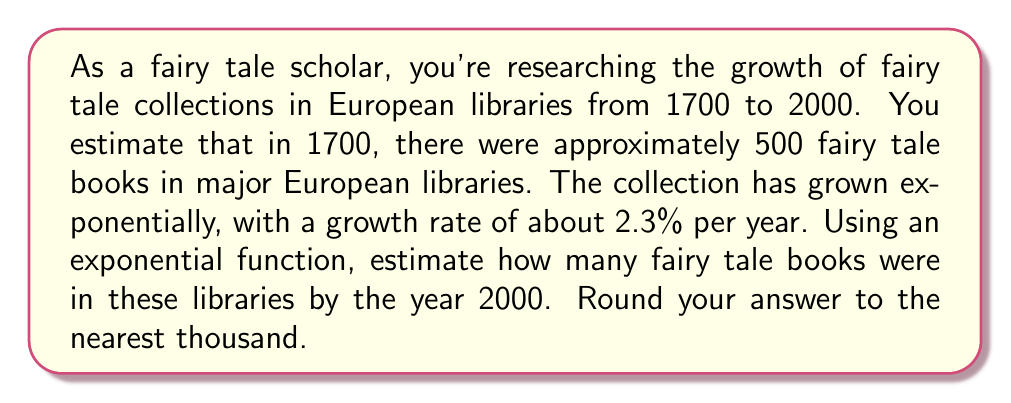Teach me how to tackle this problem. To solve this problem, we'll use the exponential growth function:

$$A(t) = A_0 \cdot (1 + r)^t$$

Where:
$A(t)$ is the amount after time $t$
$A_0$ is the initial amount
$r$ is the growth rate (as a decimal)
$t$ is the time in years

Given:
$A_0 = 500$ (initial number of books in 1700)
$r = 0.023$ (2.3% annual growth rate)
$t = 300$ (years from 1700 to 2000)

Let's substitute these values into our equation:

$$A(300) = 500 \cdot (1 + 0.023)^{300}$$

Now, let's calculate:

$$A(300) = 500 \cdot (1.023)^{300}$$

Using a calculator (as this involves a large exponent):

$$A(300) = 500 \cdot 971.2277...$$

$$A(300) = 485,613.85...$$

Rounding to the nearest thousand:

$$A(300) \approx 486,000$$
Answer: 486,000 fairy tale books 